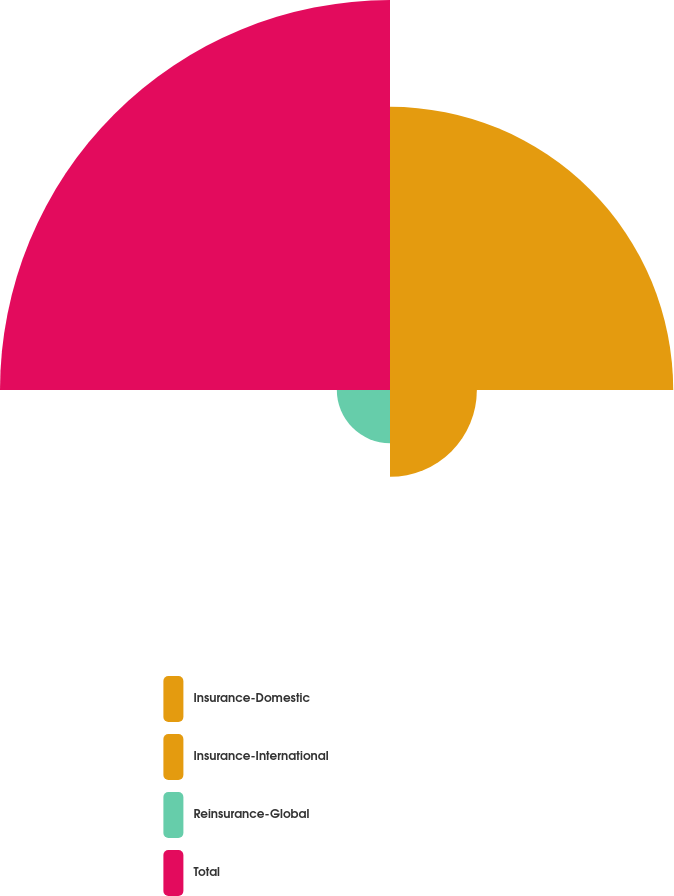<chart> <loc_0><loc_0><loc_500><loc_500><pie_chart><fcel>Insurance-Domestic<fcel>Insurance-International<fcel>Reinsurance-Global<fcel>Total<nl><fcel>34.83%<fcel>10.68%<fcel>6.54%<fcel>47.96%<nl></chart> 